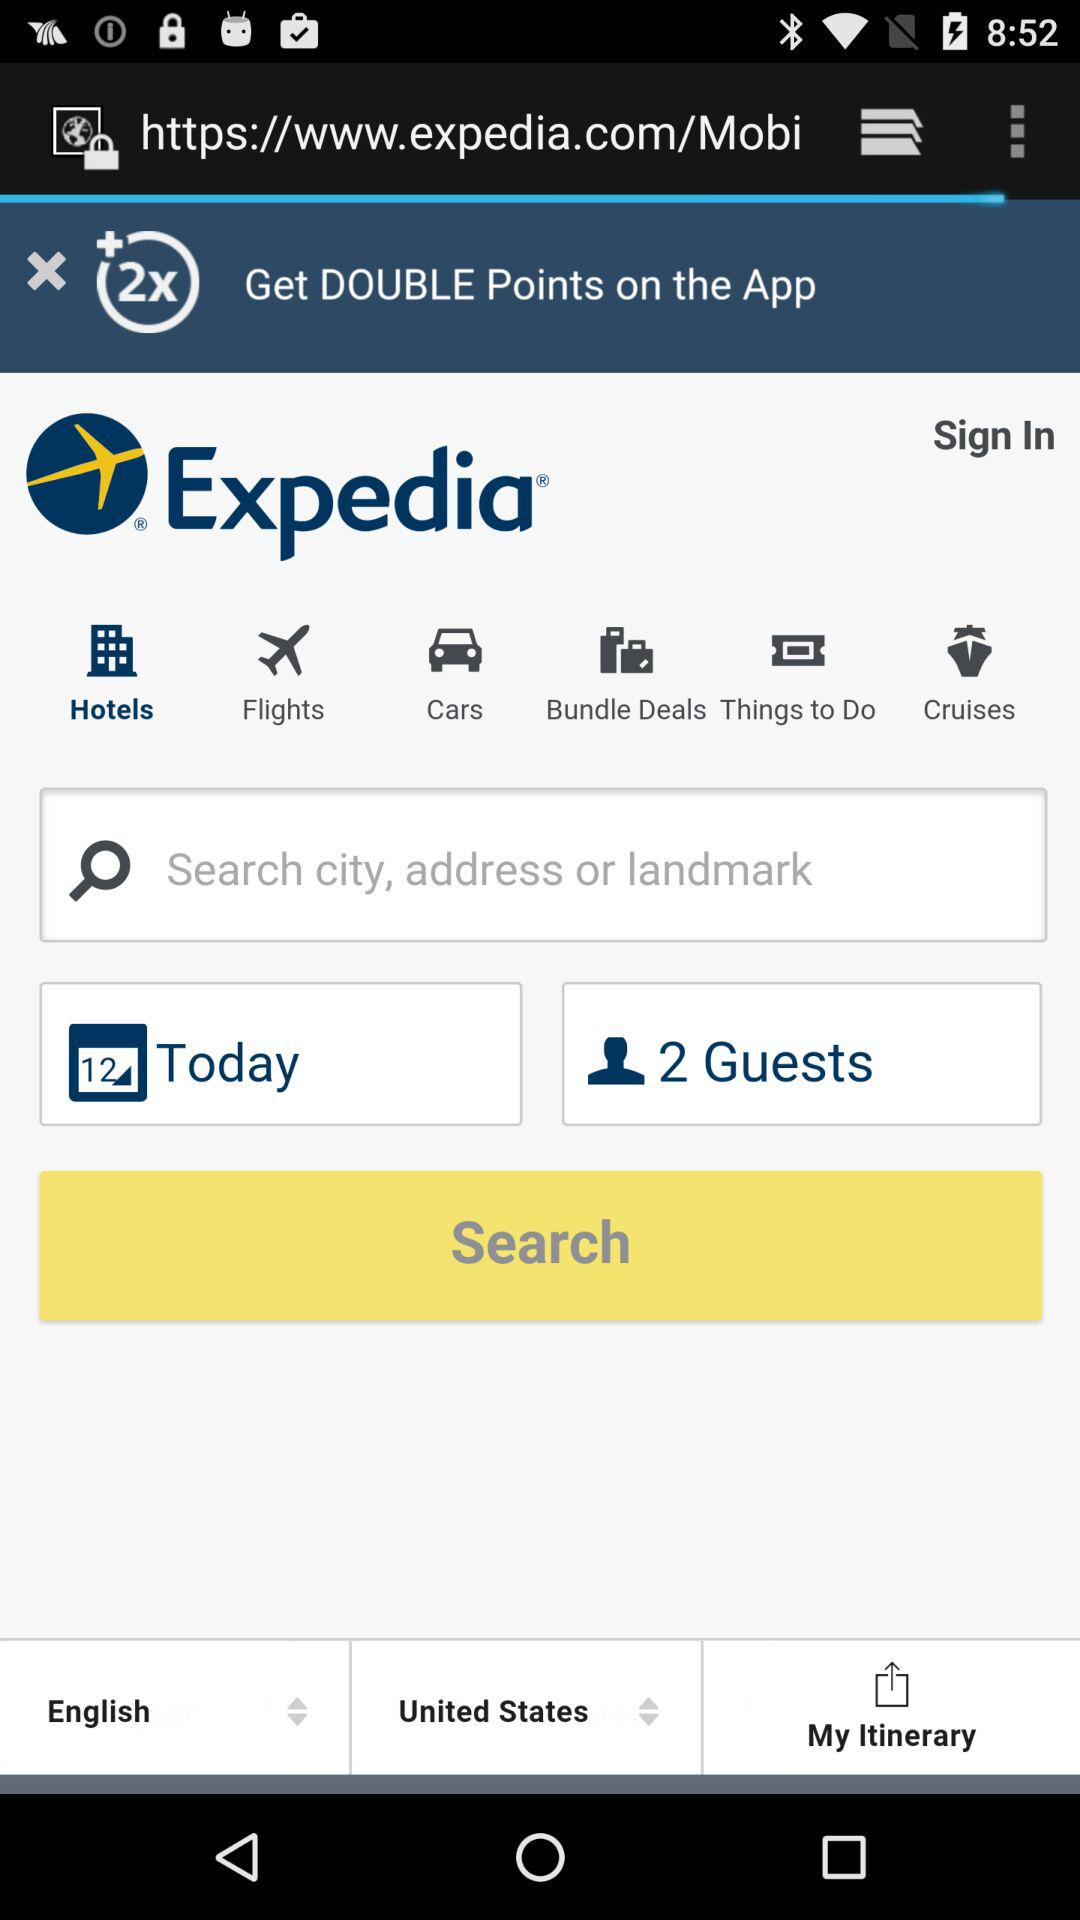Which tab is selected? The selected tab is "Hotels". 